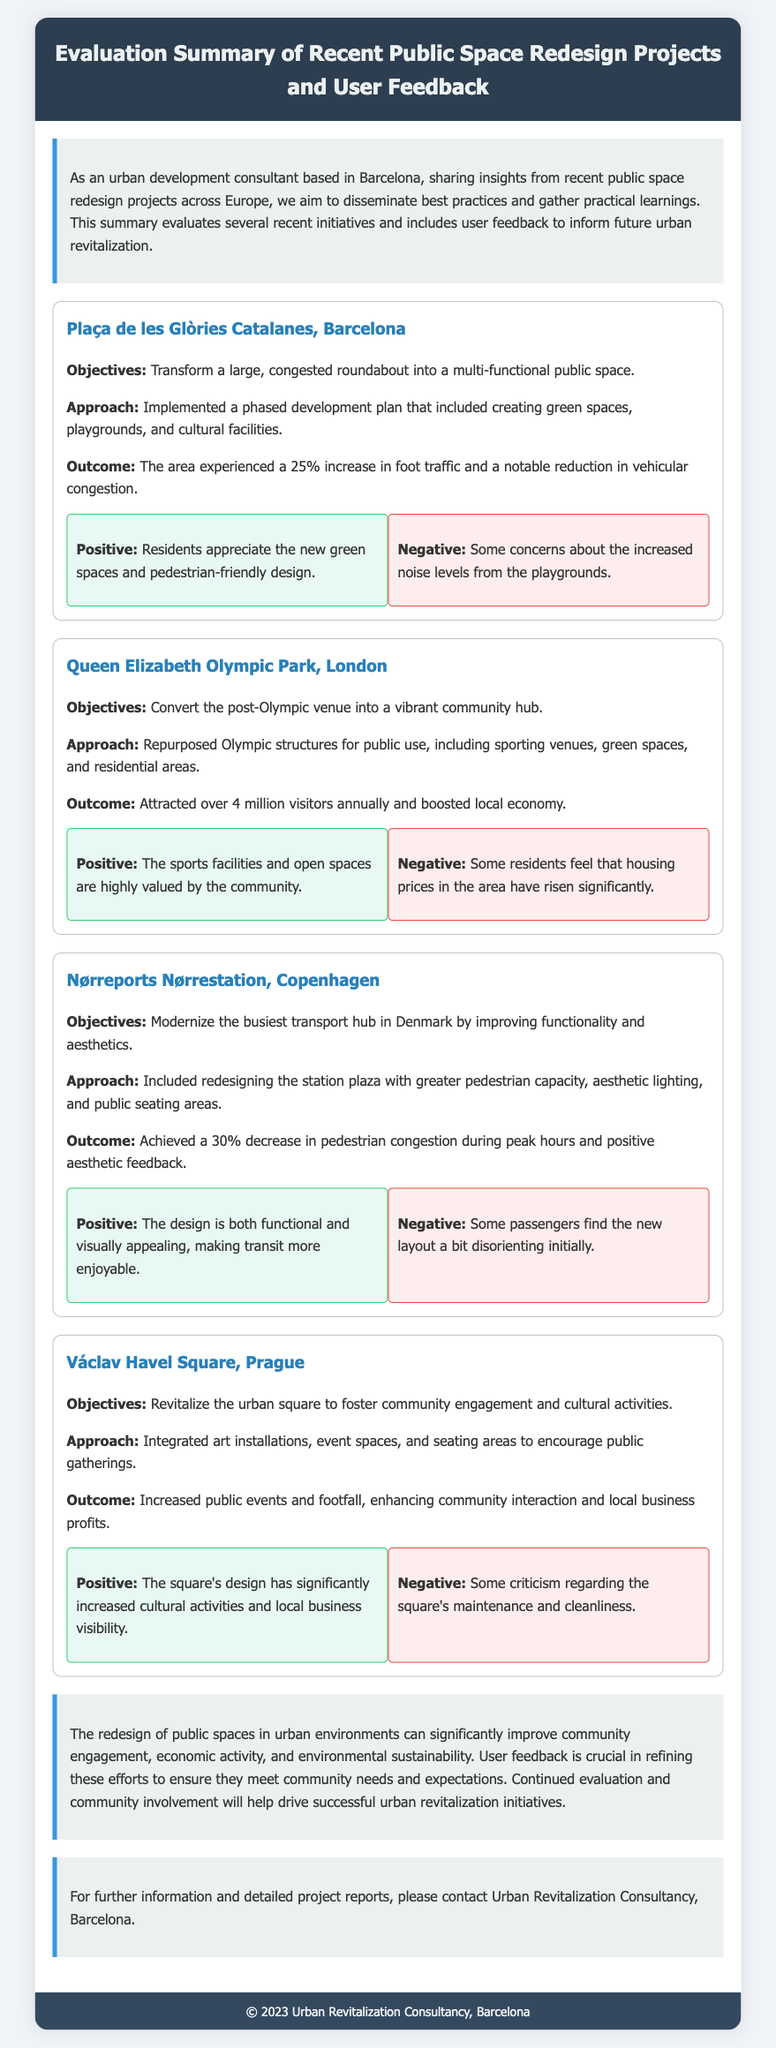what is the name of the first project? The first project listed in the document is Plaça de les Glòries Catalanes, Barcelona.
Answer: Plaça de les Glòries Catalanes, Barcelona what percentage increase in foot traffic was observed in the project at Plaça de les Glòries Catalanes? The document states that there was a 25% increase in foot traffic.
Answer: 25% how many annual visitors does the Queen Elizabeth Olympic Park attract? The document mentions that the Queen Elizabeth Olympic Park attracts over 4 million visitors annually.
Answer: over 4 million what type of feedback did residents provide about the new green spaces in Barcelona? The feedback indicated that residents appreciate the new green spaces and pedestrian-friendly design.
Answer: appreciate what was a concern residents had regarding the playgrounds in Barcelona? Some residents expressed concerns about the increased noise levels from the playgrounds.
Answer: increased noise levels what was the main objective of the Nørreports Nørrestation project? The main objective was to modernize the busiest transport hub in Denmark by improving functionality and aesthetics.
Answer: modernize the busiest transport hub which city is mentioned as the location for the Václav Havel Square project? The document specifies that the Václav Havel Square project is located in Prague.
Answer: Prague what aspect made the new design of Nørreports Nørrestation appealing to users? Users found the design to be both functional and visually appealing.
Answer: functional and visually appealing what improvement in pedestrian congestion was achieved in the Nørreports Nørrestation project? The document states that there was a 30% decrease in pedestrian congestion during peak hours.
Answer: 30% decrease 